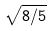<formula> <loc_0><loc_0><loc_500><loc_500>\sqrt { 8 / 5 }</formula> 